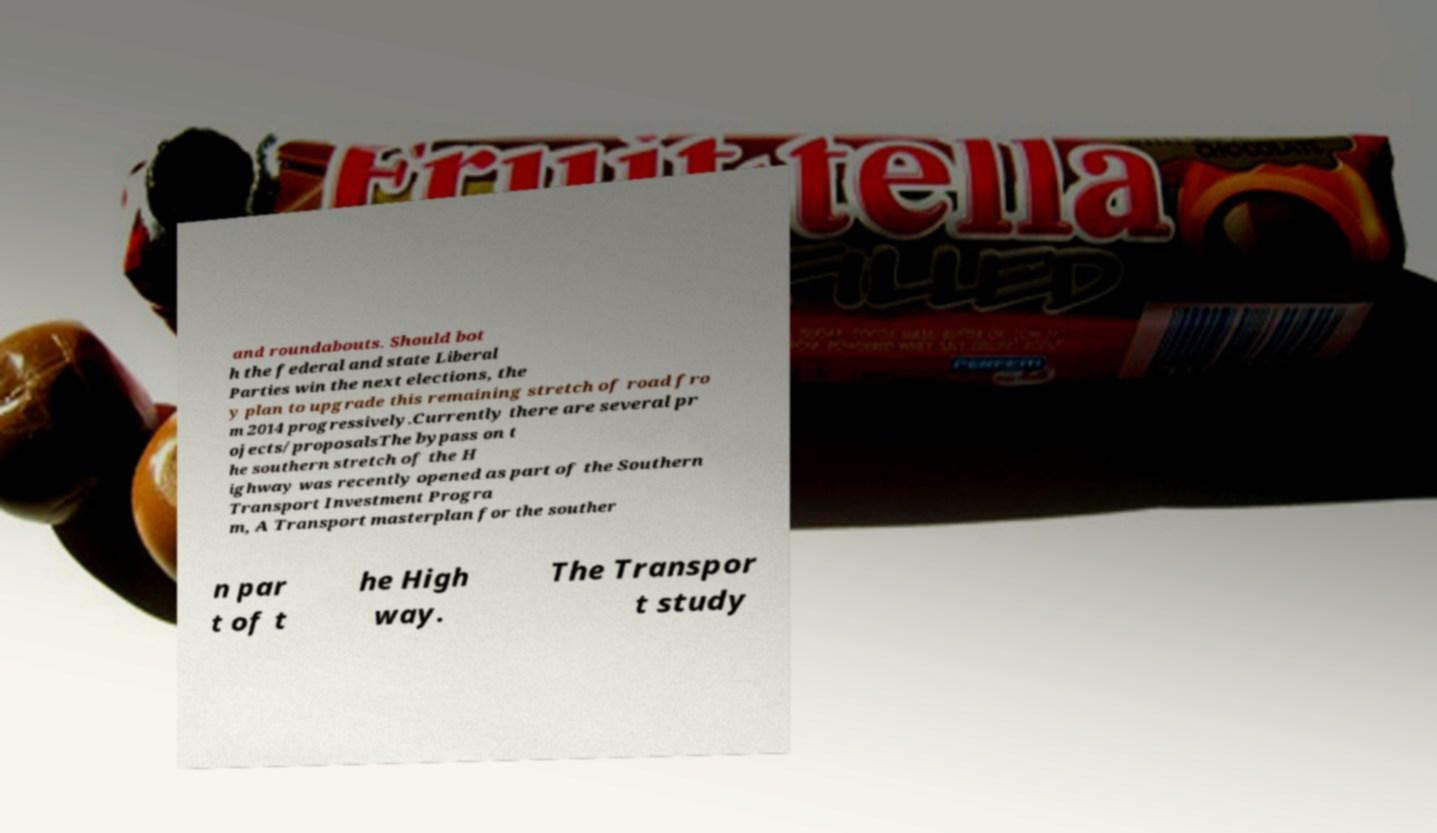Can you accurately transcribe the text from the provided image for me? and roundabouts. Should bot h the federal and state Liberal Parties win the next elections, the y plan to upgrade this remaining stretch of road fro m 2014 progressively.Currently there are several pr ojects/proposalsThe bypass on t he southern stretch of the H ighway was recently opened as part of the Southern Transport Investment Progra m, A Transport masterplan for the souther n par t of t he High way. The Transpor t study 